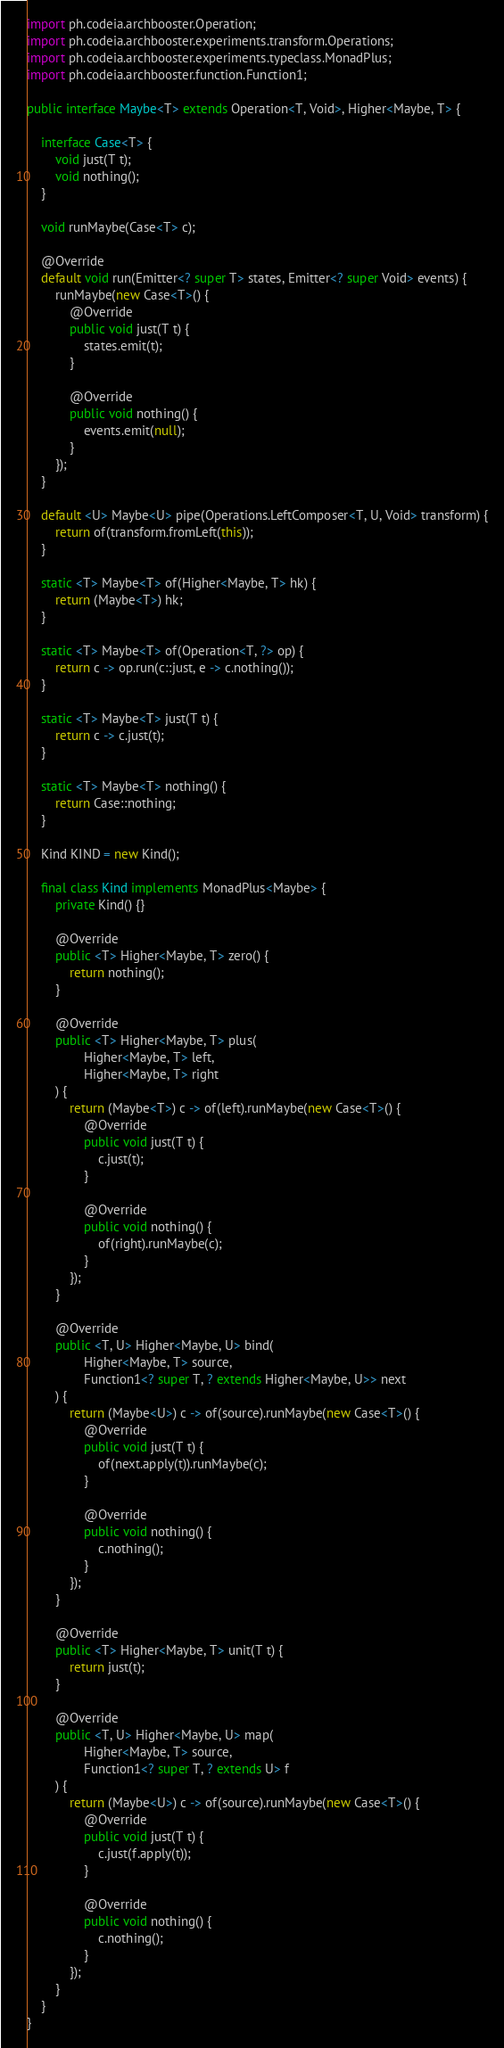Convert code to text. <code><loc_0><loc_0><loc_500><loc_500><_Java_>import ph.codeia.archbooster.Operation;
import ph.codeia.archbooster.experiments.transform.Operations;
import ph.codeia.archbooster.experiments.typeclass.MonadPlus;
import ph.codeia.archbooster.function.Function1;

public interface Maybe<T> extends Operation<T, Void>, Higher<Maybe, T> {

    interface Case<T> {
        void just(T t);
        void nothing();
    }

    void runMaybe(Case<T> c);

    @Override
    default void run(Emitter<? super T> states, Emitter<? super Void> events) {
        runMaybe(new Case<T>() {
            @Override
            public void just(T t) {
                states.emit(t);
            }

            @Override
            public void nothing() {
                events.emit(null);
            }
        });
    }

    default <U> Maybe<U> pipe(Operations.LeftComposer<T, U, Void> transform) {
        return of(transform.fromLeft(this));
    }

    static <T> Maybe<T> of(Higher<Maybe, T> hk) {
        return (Maybe<T>) hk;
    }

    static <T> Maybe<T> of(Operation<T, ?> op) {
        return c -> op.run(c::just, e -> c.nothing());
    }

    static <T> Maybe<T> just(T t) {
        return c -> c.just(t);
    }

    static <T> Maybe<T> nothing() {
        return Case::nothing;
    }

    Kind KIND = new Kind();

    final class Kind implements MonadPlus<Maybe> {
        private Kind() {}

        @Override
        public <T> Higher<Maybe, T> zero() {
            return nothing();
        }

        @Override
        public <T> Higher<Maybe, T> plus(
                Higher<Maybe, T> left,
                Higher<Maybe, T> right
        ) {
            return (Maybe<T>) c -> of(left).runMaybe(new Case<T>() {
                @Override
                public void just(T t) {
                    c.just(t);
                }

                @Override
                public void nothing() {
                    of(right).runMaybe(c);
                }
            });
        }

        @Override
        public <T, U> Higher<Maybe, U> bind(
                Higher<Maybe, T> source,
                Function1<? super T, ? extends Higher<Maybe, U>> next
        ) {
            return (Maybe<U>) c -> of(source).runMaybe(new Case<T>() {
                @Override
                public void just(T t) {
                    of(next.apply(t)).runMaybe(c);
                }

                @Override
                public void nothing() {
                    c.nothing();
                }
            });
        }

        @Override
        public <T> Higher<Maybe, T> unit(T t) {
            return just(t);
        }

        @Override
        public <T, U> Higher<Maybe, U> map(
                Higher<Maybe, T> source,
                Function1<? super T, ? extends U> f
        ) {
            return (Maybe<U>) c -> of(source).runMaybe(new Case<T>() {
                @Override
                public void just(T t) {
                    c.just(f.apply(t));
                }

                @Override
                public void nothing() {
                    c.nothing();
                }
            });
        }
    }
}
</code> 